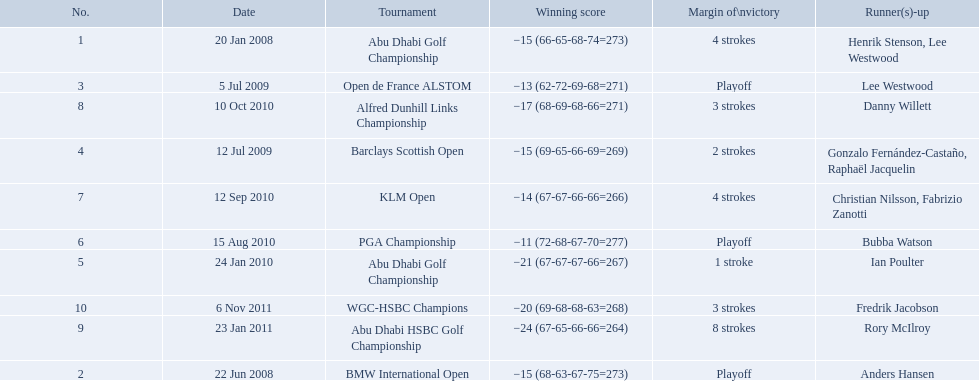What were the margins of victories of the tournaments? 4 strokes, Playoff, Playoff, 2 strokes, 1 stroke, Playoff, 4 strokes, 3 strokes, 8 strokes, 3 strokes. Of these, what was the margin of victory of the klm and the barklay 2 strokes, 4 strokes. What were the difference between these? 2 strokes. 